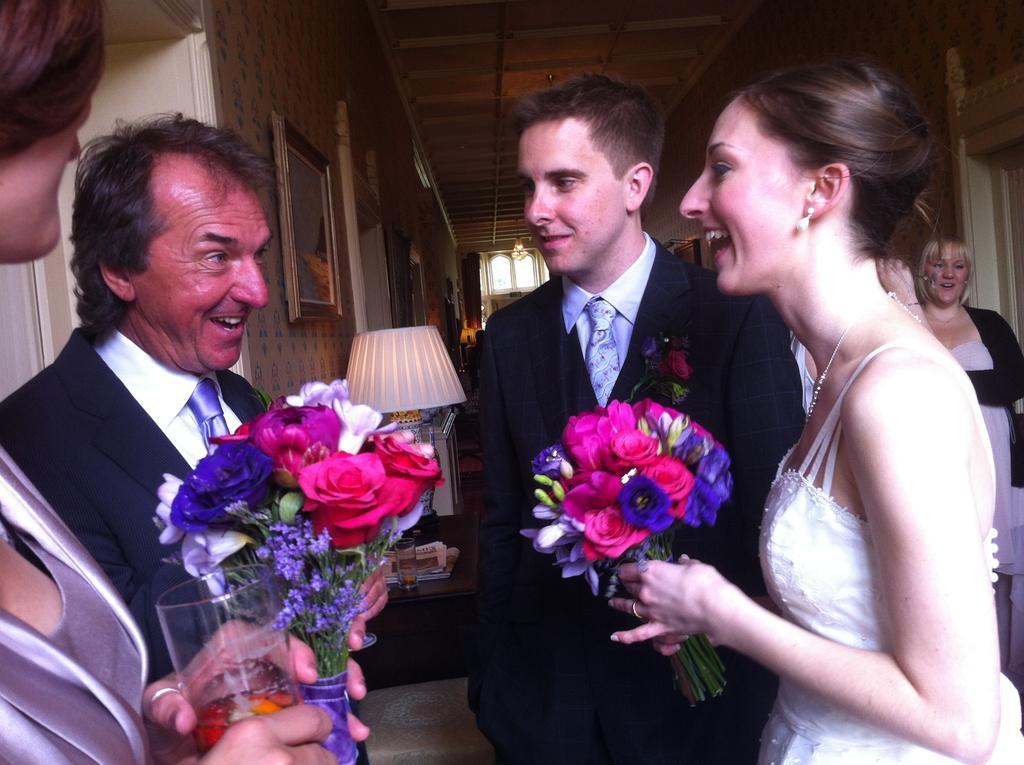Please provide a concise description of this image. In this image I can see a woman wearing white colored dress and two men wearing black colored blazers are standing. I can see two persons are holding flower bouquets in their hands which are pink, violet and blue in color. I can see a woman is holding a glass in her hand. In the background I can see a wall, a photo frame, a lamp, a window, the ceiling and few persons standing. 